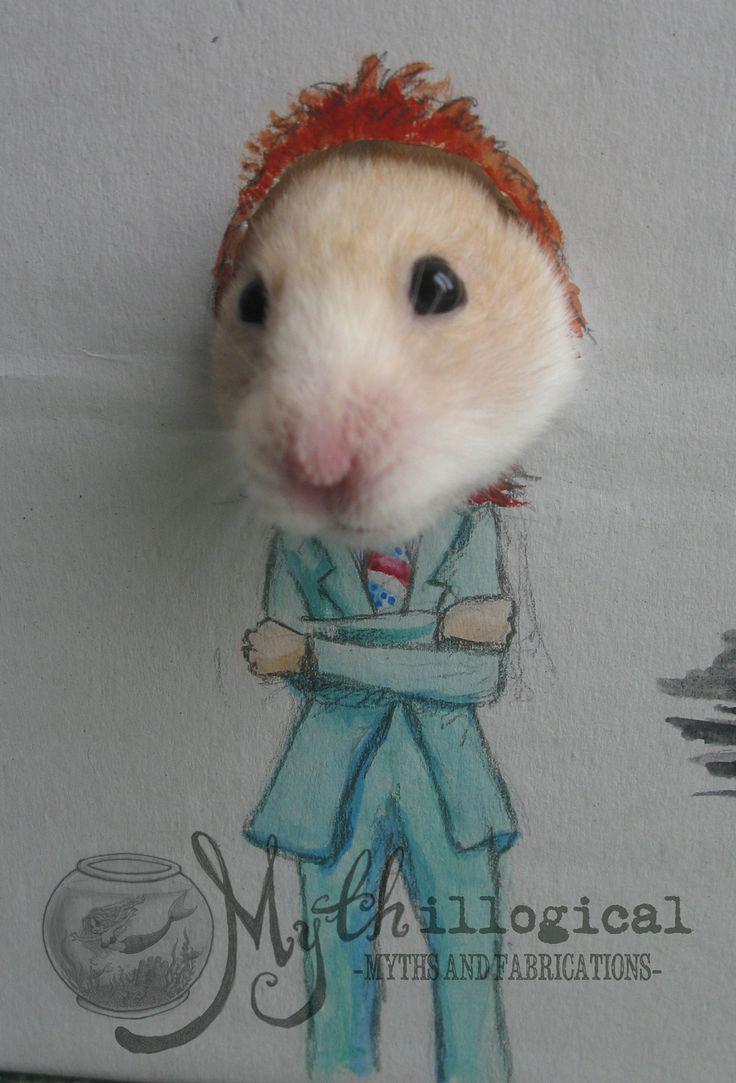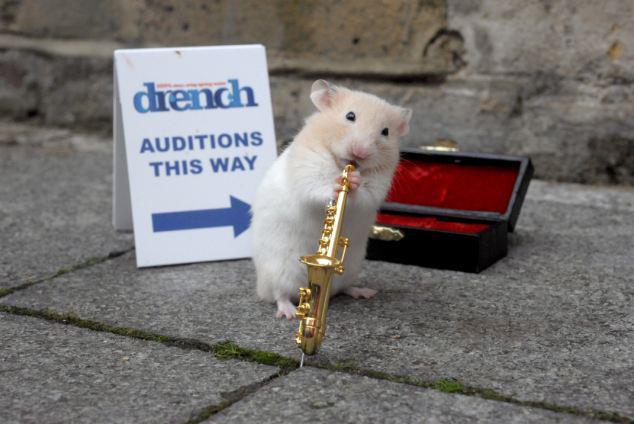The first image is the image on the left, the second image is the image on the right. Analyze the images presented: Is the assertion "In at least one of the images there is a rodent playing an instrument" valid? Answer yes or no. Yes. The first image is the image on the left, the second image is the image on the right. Examine the images to the left and right. Is the description "There is at least one hamster playing a miniature saxophone." accurate? Answer yes or no. Yes. 